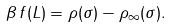Convert formula to latex. <formula><loc_0><loc_0><loc_500><loc_500>\beta \, f ( L ) = \rho ( \sigma ) - \rho _ { \infty } ( \sigma ) .</formula> 